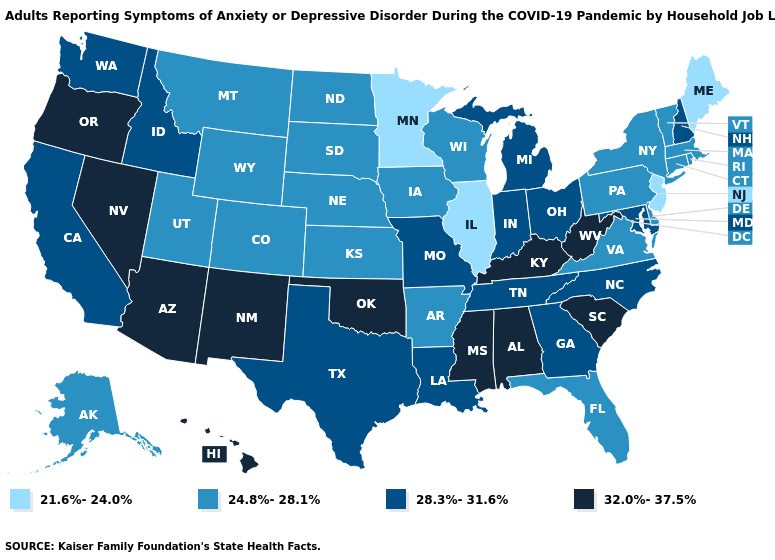Which states have the lowest value in the South?
Answer briefly. Arkansas, Delaware, Florida, Virginia. Does Missouri have the same value as Pennsylvania?
Answer briefly. No. Does Mississippi have the highest value in the USA?
Concise answer only. Yes. What is the value of Georgia?
Write a very short answer. 28.3%-31.6%. Among the states that border Maryland , does Pennsylvania have the lowest value?
Write a very short answer. Yes. Does Florida have the lowest value in the USA?
Answer briefly. No. Name the states that have a value in the range 21.6%-24.0%?
Give a very brief answer. Illinois, Maine, Minnesota, New Jersey. Which states have the lowest value in the Northeast?
Answer briefly. Maine, New Jersey. Is the legend a continuous bar?
Give a very brief answer. No. Name the states that have a value in the range 24.8%-28.1%?
Short answer required. Alaska, Arkansas, Colorado, Connecticut, Delaware, Florida, Iowa, Kansas, Massachusetts, Montana, Nebraska, New York, North Dakota, Pennsylvania, Rhode Island, South Dakota, Utah, Vermont, Virginia, Wisconsin, Wyoming. Among the states that border Kentucky , which have the lowest value?
Short answer required. Illinois. Name the states that have a value in the range 24.8%-28.1%?
Concise answer only. Alaska, Arkansas, Colorado, Connecticut, Delaware, Florida, Iowa, Kansas, Massachusetts, Montana, Nebraska, New York, North Dakota, Pennsylvania, Rhode Island, South Dakota, Utah, Vermont, Virginia, Wisconsin, Wyoming. Does Washington have the same value as South Dakota?
Quick response, please. No. Which states hav the highest value in the MidWest?
Short answer required. Indiana, Michigan, Missouri, Ohio. 